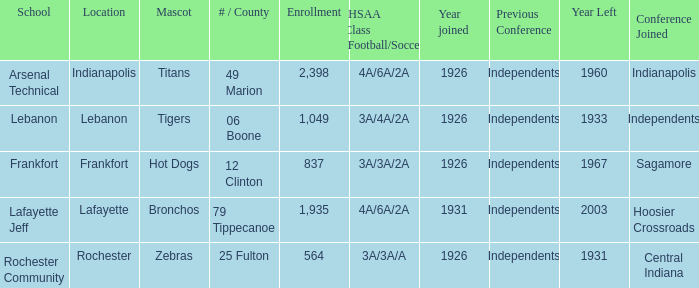What is the average enrollment that has hot dogs as the mascot, with a year joined later than 1926? None. 